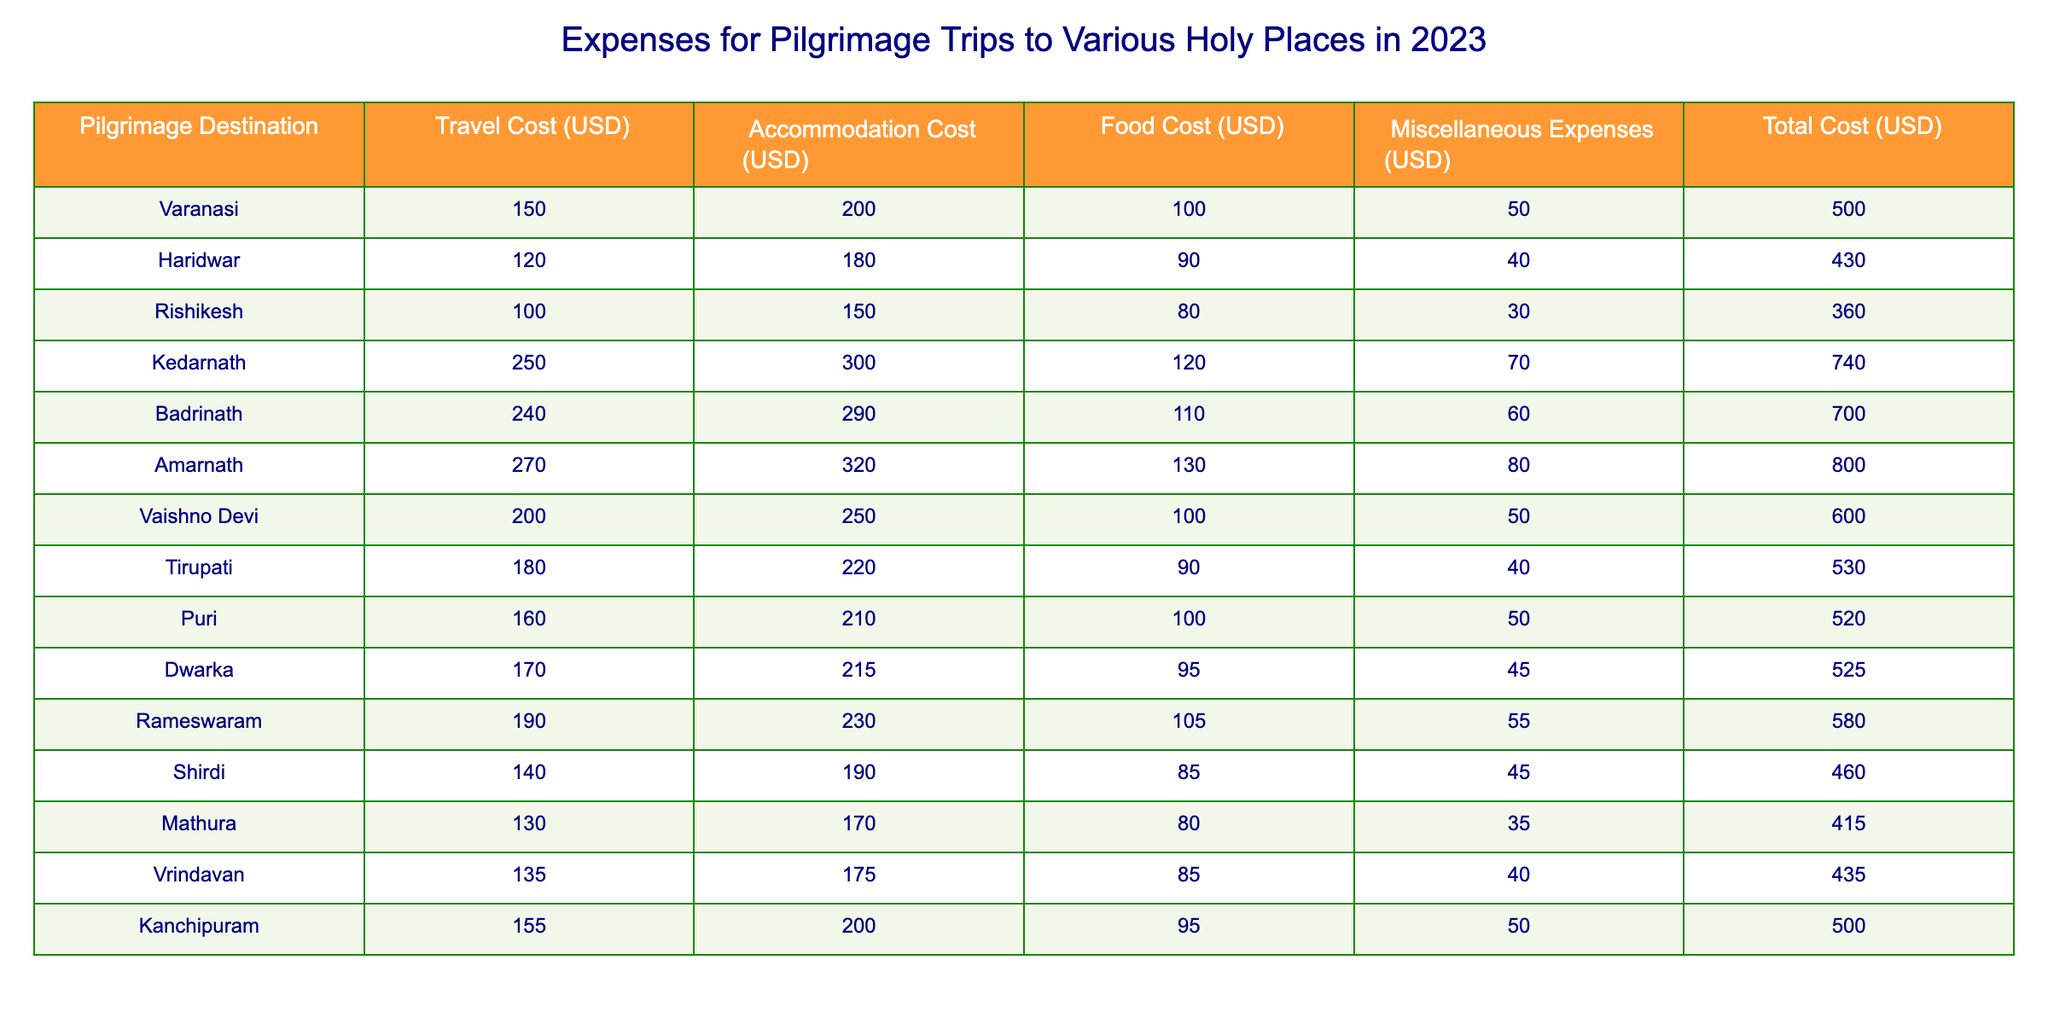What is the total cost for a trip to Amarnath? From the table, the total cost for Amarnath is listed under the "Total Cost (USD)" column, which is 800 USD.
Answer: 800 USD Which pilgrimage destination has the highest food cost? To find the highest food cost, we look at the "Food Cost (USD)" column and compare values. Amarnath has the highest food cost at 130 USD.
Answer: Amarnath What is the average total cost of all pilgrimage trips listed? We first sum the total costs: 500 + 430 + 360 + 740 + 700 + 800 + 600 + 530 + 520 + 525 + 580 + 460 + 415 + 435 + 500 = 8680. There are 15 trips, so the average total cost is 8680/15 = 578.67 USD.
Answer: 578.67 USD Is the accommodation cost for Rishikesh lower than the average accommodation cost of all listed destinations? The average accommodation cost is calculated by summing the accommodation costs: 200 + 180 + 150 + 300 + 290 + 320 + 250 + 220 + 210 + 215 + 230 + 190 + 170 + 175 + 200 = 2930. There are 15 destinations, so the average is 2930/15 = 195.33 USD. Rishikesh has an accommodation cost of 150 USD, which is lower than 195.33 USD.
Answer: Yes What is the difference in total cost between Kedarnath and Haridwar? The total cost for Kedarnath is 740 USD, and for Haridwar it is 430 USD. To find the difference, we subtract: 740 - 430 = 310 USD.
Answer: 310 USD Does the cost of pilgrimage to Vaishno Devi exceed 600 USD? The total cost for Vaishno Devi is listed as 600 USD. Since it does not exceed 600, we answer no.
Answer: No Which destinations have a total cost of less than 500 USD? Looking at the "Total Cost (USD)" column, we see that the following destinations have costs less than 500 USD: Rishikesh (360 USD), Shirdi (460 USD), and Mathura (415 USD).
Answer: Rishikesh, Shirdi, Mathura What is the sum of food and travel costs for Badrinath? The travel cost for Badrinath is 240 USD, and the food cost is 110 USD. The sum is: 240 + 110 = 350 USD.
Answer: 350 USD 